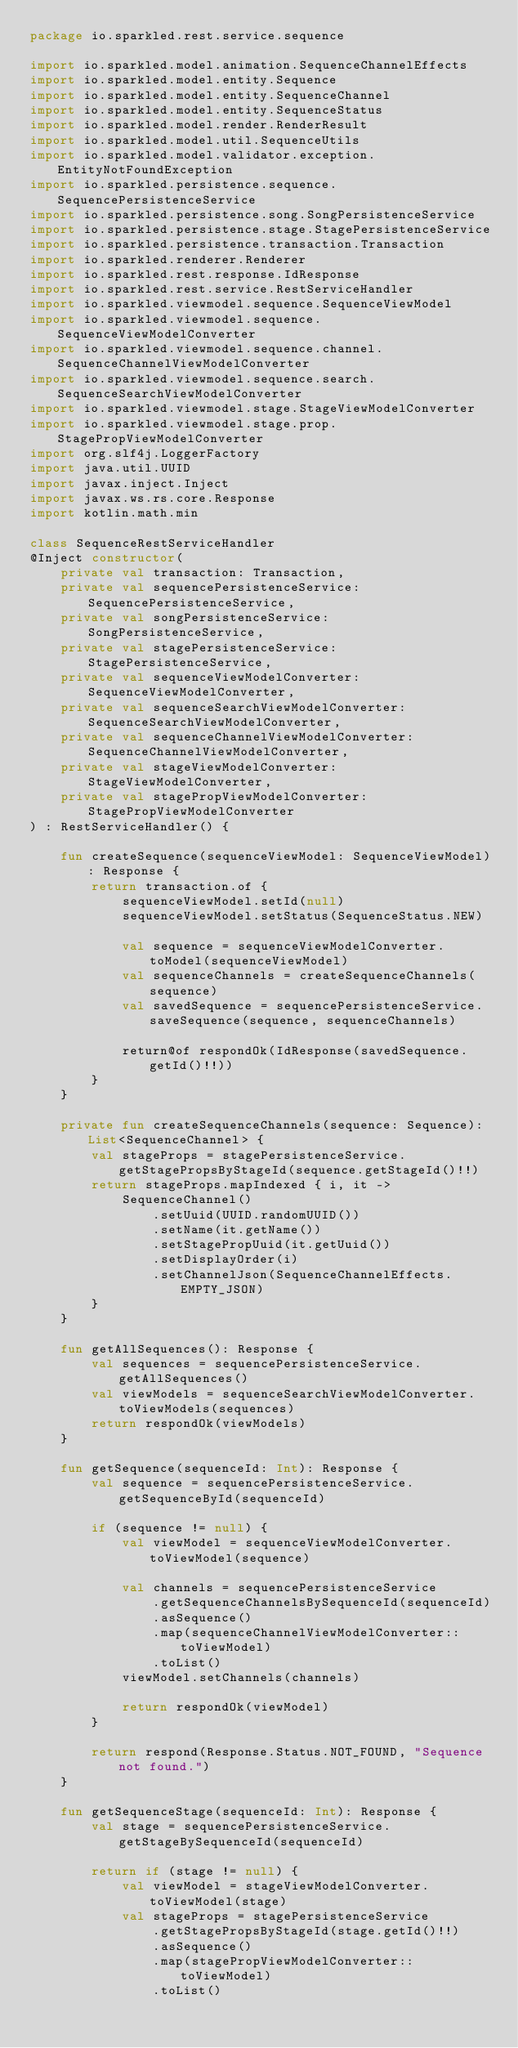Convert code to text. <code><loc_0><loc_0><loc_500><loc_500><_Kotlin_>package io.sparkled.rest.service.sequence

import io.sparkled.model.animation.SequenceChannelEffects
import io.sparkled.model.entity.Sequence
import io.sparkled.model.entity.SequenceChannel
import io.sparkled.model.entity.SequenceStatus
import io.sparkled.model.render.RenderResult
import io.sparkled.model.util.SequenceUtils
import io.sparkled.model.validator.exception.EntityNotFoundException
import io.sparkled.persistence.sequence.SequencePersistenceService
import io.sparkled.persistence.song.SongPersistenceService
import io.sparkled.persistence.stage.StagePersistenceService
import io.sparkled.persistence.transaction.Transaction
import io.sparkled.renderer.Renderer
import io.sparkled.rest.response.IdResponse
import io.sparkled.rest.service.RestServiceHandler
import io.sparkled.viewmodel.sequence.SequenceViewModel
import io.sparkled.viewmodel.sequence.SequenceViewModelConverter
import io.sparkled.viewmodel.sequence.channel.SequenceChannelViewModelConverter
import io.sparkled.viewmodel.sequence.search.SequenceSearchViewModelConverter
import io.sparkled.viewmodel.stage.StageViewModelConverter
import io.sparkled.viewmodel.stage.prop.StagePropViewModelConverter
import org.slf4j.LoggerFactory
import java.util.UUID
import javax.inject.Inject
import javax.ws.rs.core.Response
import kotlin.math.min

class SequenceRestServiceHandler
@Inject constructor(
    private val transaction: Transaction,
    private val sequencePersistenceService: SequencePersistenceService,
    private val songPersistenceService: SongPersistenceService,
    private val stagePersistenceService: StagePersistenceService,
    private val sequenceViewModelConverter: SequenceViewModelConverter,
    private val sequenceSearchViewModelConverter: SequenceSearchViewModelConverter,
    private val sequenceChannelViewModelConverter: SequenceChannelViewModelConverter,
    private val stageViewModelConverter: StageViewModelConverter,
    private val stagePropViewModelConverter: StagePropViewModelConverter
) : RestServiceHandler() {

    fun createSequence(sequenceViewModel: SequenceViewModel): Response {
        return transaction.of {
            sequenceViewModel.setId(null)
            sequenceViewModel.setStatus(SequenceStatus.NEW)

            val sequence = sequenceViewModelConverter.toModel(sequenceViewModel)
            val sequenceChannels = createSequenceChannels(sequence)
            val savedSequence = sequencePersistenceService.saveSequence(sequence, sequenceChannels)

            return@of respondOk(IdResponse(savedSequence.getId()!!))
        }
    }

    private fun createSequenceChannels(sequence: Sequence): List<SequenceChannel> {
        val stageProps = stagePersistenceService.getStagePropsByStageId(sequence.getStageId()!!)
        return stageProps.mapIndexed { i, it ->
            SequenceChannel()
                .setUuid(UUID.randomUUID())
                .setName(it.getName())
                .setStagePropUuid(it.getUuid())
                .setDisplayOrder(i)
                .setChannelJson(SequenceChannelEffects.EMPTY_JSON)
        }
    }

    fun getAllSequences(): Response {
        val sequences = sequencePersistenceService.getAllSequences()
        val viewModels = sequenceSearchViewModelConverter.toViewModels(sequences)
        return respondOk(viewModels)
    }

    fun getSequence(sequenceId: Int): Response {
        val sequence = sequencePersistenceService.getSequenceById(sequenceId)

        if (sequence != null) {
            val viewModel = sequenceViewModelConverter.toViewModel(sequence)

            val channels = sequencePersistenceService
                .getSequenceChannelsBySequenceId(sequenceId)
                .asSequence()
                .map(sequenceChannelViewModelConverter::toViewModel)
                .toList()
            viewModel.setChannels(channels)

            return respondOk(viewModel)
        }

        return respond(Response.Status.NOT_FOUND, "Sequence not found.")
    }

    fun getSequenceStage(sequenceId: Int): Response {
        val stage = sequencePersistenceService.getStageBySequenceId(sequenceId)

        return if (stage != null) {
            val viewModel = stageViewModelConverter.toViewModel(stage)
            val stageProps = stagePersistenceService
                .getStagePropsByStageId(stage.getId()!!)
                .asSequence()
                .map(stagePropViewModelConverter::toViewModel)
                .toList()
</code> 